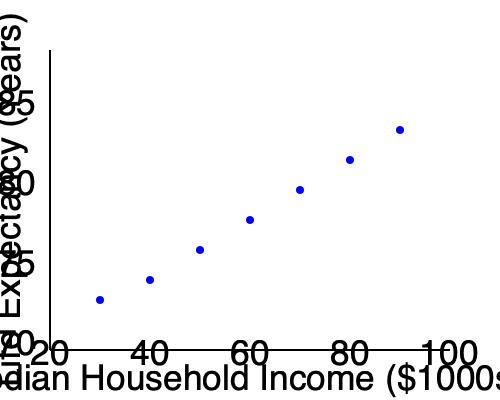Based on the scatter plot showing the relationship between median household income and life expectancy, what conclusion can be drawn about the impact of socioeconomic factors on health disparities? How might this information guide strategies to address healthcare inequities? To interpret the scatter plot and draw conclusions about the impact of socioeconomic factors on health disparities, we need to follow these steps:

1. Observe the overall trend:
   The scatter plot shows a clear positive correlation between median household income and life expectancy.

2. Analyze the relationship:
   As median household income increases, life expectancy tends to increase as well. This suggests a strong link between socioeconomic status and health outcomes.

3. Consider the implications:
   The relationship indicates that individuals with higher incomes generally have longer life expectancies, pointing to significant health disparities based on socioeconomic factors.

4. Identify potential causes:
   Higher income may lead to better access to healthcare, healthier living conditions, better nutrition, and reduced stress, all of which can contribute to longer life expectancy.

5. Recognize the complexity:
   While the trend is clear, it's important to note that correlation does not imply causation, and other factors may also influence this relationship.

6. Apply to healthcare strategies:
   This information can guide strategies to address healthcare inequities by:
   a) Targeting resources and interventions to lower-income communities
   b) Advocating for policies that address income inequality
   c) Developing programs to improve access to quality healthcare for lower-income individuals
   d) Focusing on social determinants of health in addition to medical care

7. Consider long-term impact:
   Addressing these socioeconomic factors could potentially lead to a more equitable distribution of health outcomes across different income levels.
Answer: The scatter plot reveals a positive correlation between income and life expectancy, indicating significant health disparities based on socioeconomic status. This suggests that strategies to address healthcare inequities should focus on improving access to quality healthcare and addressing social determinants of health in lower-income communities. 